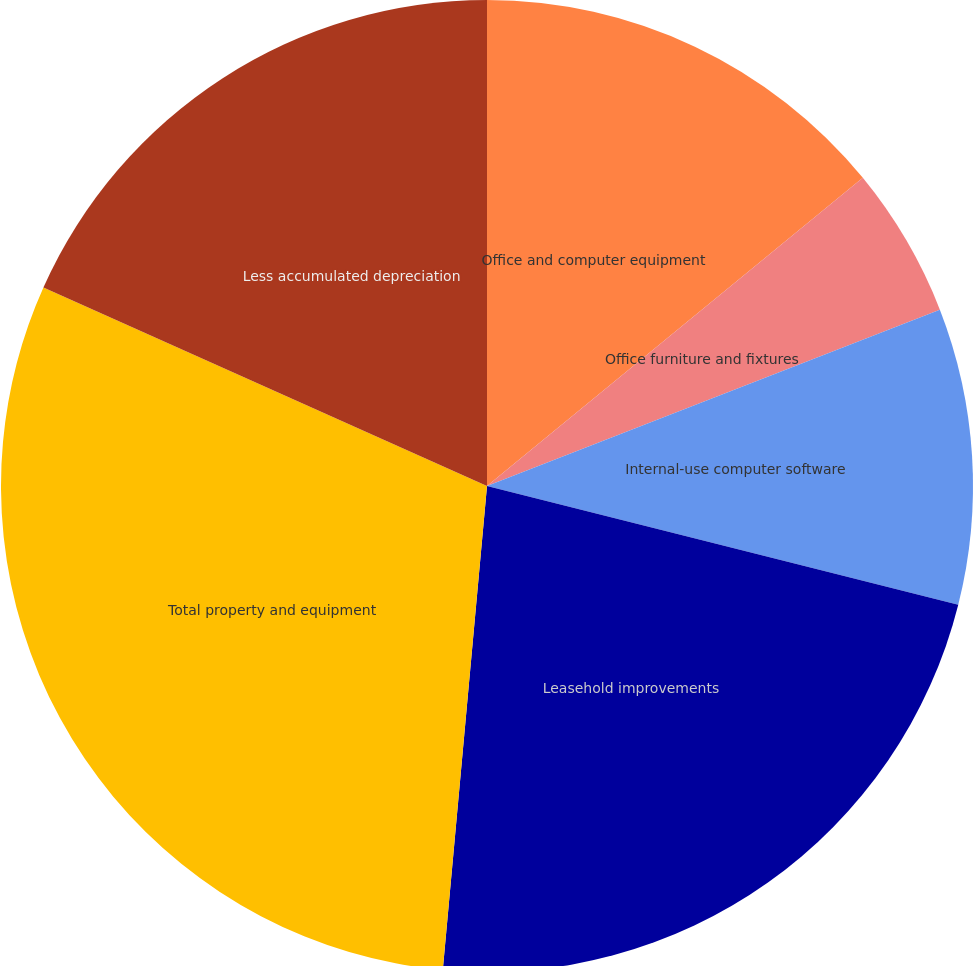Convert chart to OTSL. <chart><loc_0><loc_0><loc_500><loc_500><pie_chart><fcel>Office and computer equipment<fcel>Office furniture and fixtures<fcel>Internal-use computer software<fcel>Leasehold improvements<fcel>Total property and equipment<fcel>Less accumulated depreciation<nl><fcel>14.07%<fcel>5.02%<fcel>9.84%<fcel>22.52%<fcel>30.25%<fcel>18.3%<nl></chart> 